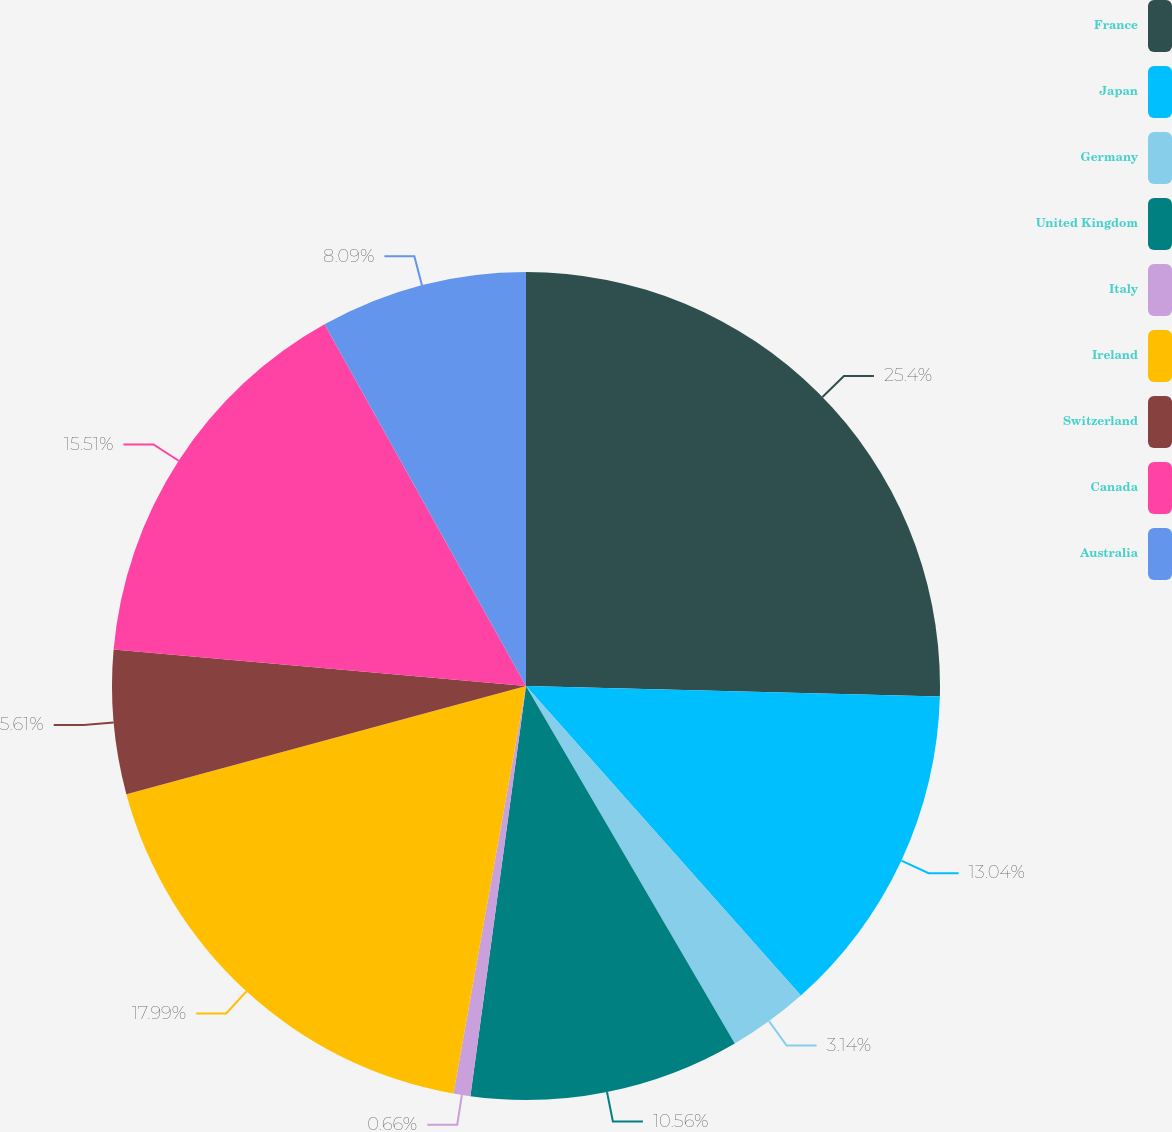Convert chart to OTSL. <chart><loc_0><loc_0><loc_500><loc_500><pie_chart><fcel>France<fcel>Japan<fcel>Germany<fcel>United Kingdom<fcel>Italy<fcel>Ireland<fcel>Switzerland<fcel>Canada<fcel>Australia<nl><fcel>25.41%<fcel>13.04%<fcel>3.14%<fcel>10.56%<fcel>0.66%<fcel>17.99%<fcel>5.61%<fcel>15.51%<fcel>8.09%<nl></chart> 